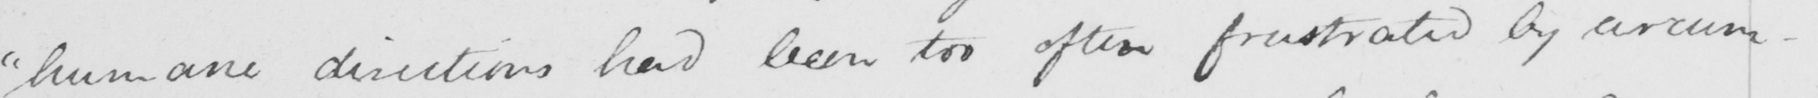What text is written in this handwritten line? " humane directions had been too often frustrated by circum- 